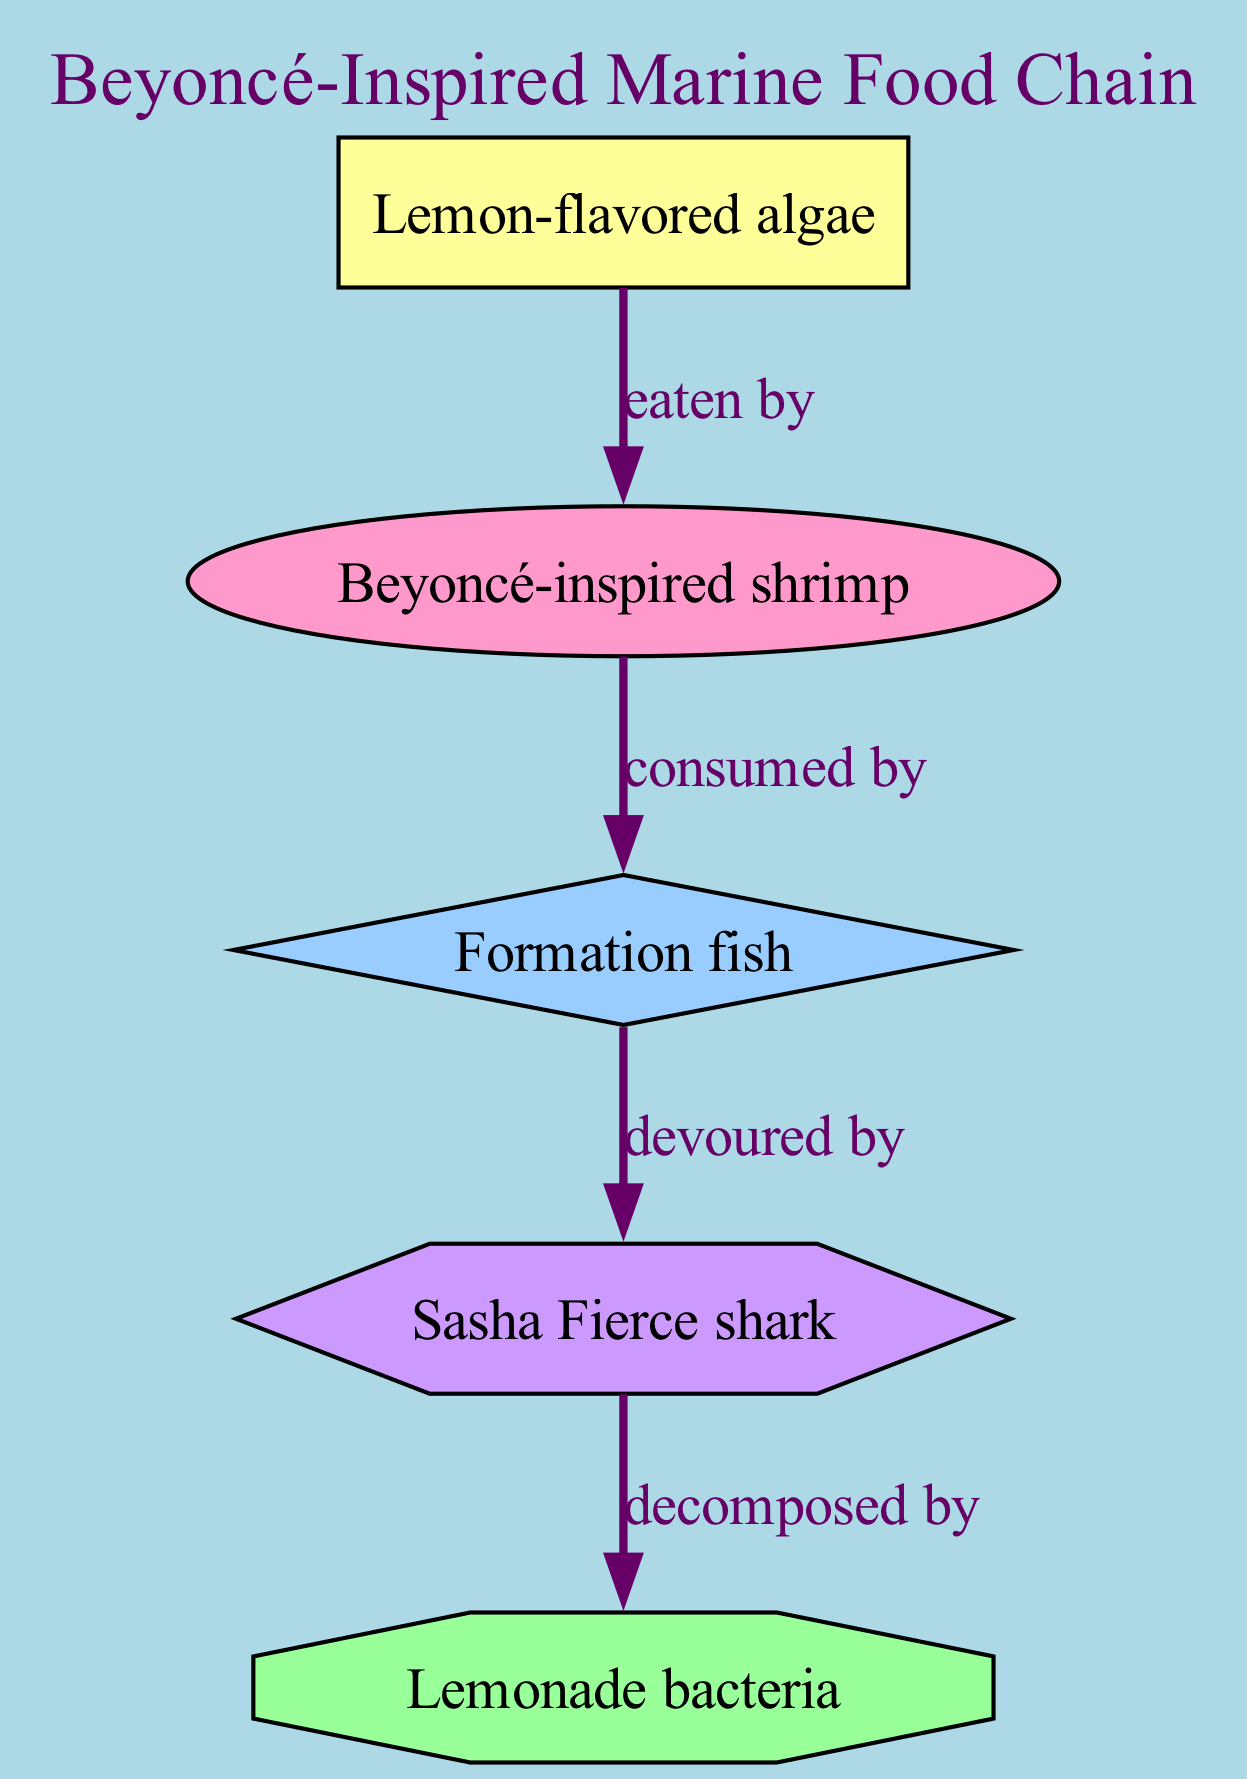What's the primary producer in the diagram? The primary producer is the first node in the food chain. Referring to the diagram, it is labeled "Lemon-flavored algae."
Answer: Lemon-flavored algae How many nodes are in the marine food chain? The diagram includes distinct elements representing producers, consumers, and decomposers. Counting all unique nodes gives a total of five nodes.
Answer: 5 Who is the secondary consumer? In the diagram, the secondary consumer is the node that is consumed by the tertiary consumer. This node is labeled "Formation fish."
Answer: Formation fish What type of consumer is the "Beyoncé-inspired shrimp"? The diagram categorizes "Beyoncé-inspired shrimp" as a primary consumer since it is the first consumer level in the food chain and consumes the producer.
Answer: primary consumer Which organism is decomposed by the "Lemonade bacteria"? The "Lemonade bacteria" decomposes the last consumer in the chain, which is the "Sasha Fierce shark." This relationship can be traced back through the diagram.
Answer: Sasha Fierce shark Which relationship connects the primary consumer to the secondary consumer? The relationship that connects these two consumers is labeled "consumed by," indicating that the primary consumer is the prey of the secondary consumer.
Answer: consumed by What color represents the decomposer in the diagram? Each type of organism has a specific color in the diagram. The decomposer is represented by an octagon filled with light green color (#99FF99).
Answer: light green Who eats the "Lemon-flavored algae"? According to the diagram, the "Beyoncé-inspired shrimp" directly consumes the "Lemon-flavored algae," establishing a direct predator-prey relationship.
Answer: Beyoncé-inspired shrimp What distinguishes the "Sasha Fierce shark" in the food chain? The "Sasha Fierce shark" is the only tertiary consumer in the diagram, indicated by its unique hexagonal shape. This distinguishes it from the others.
Answer: tertiary consumer 